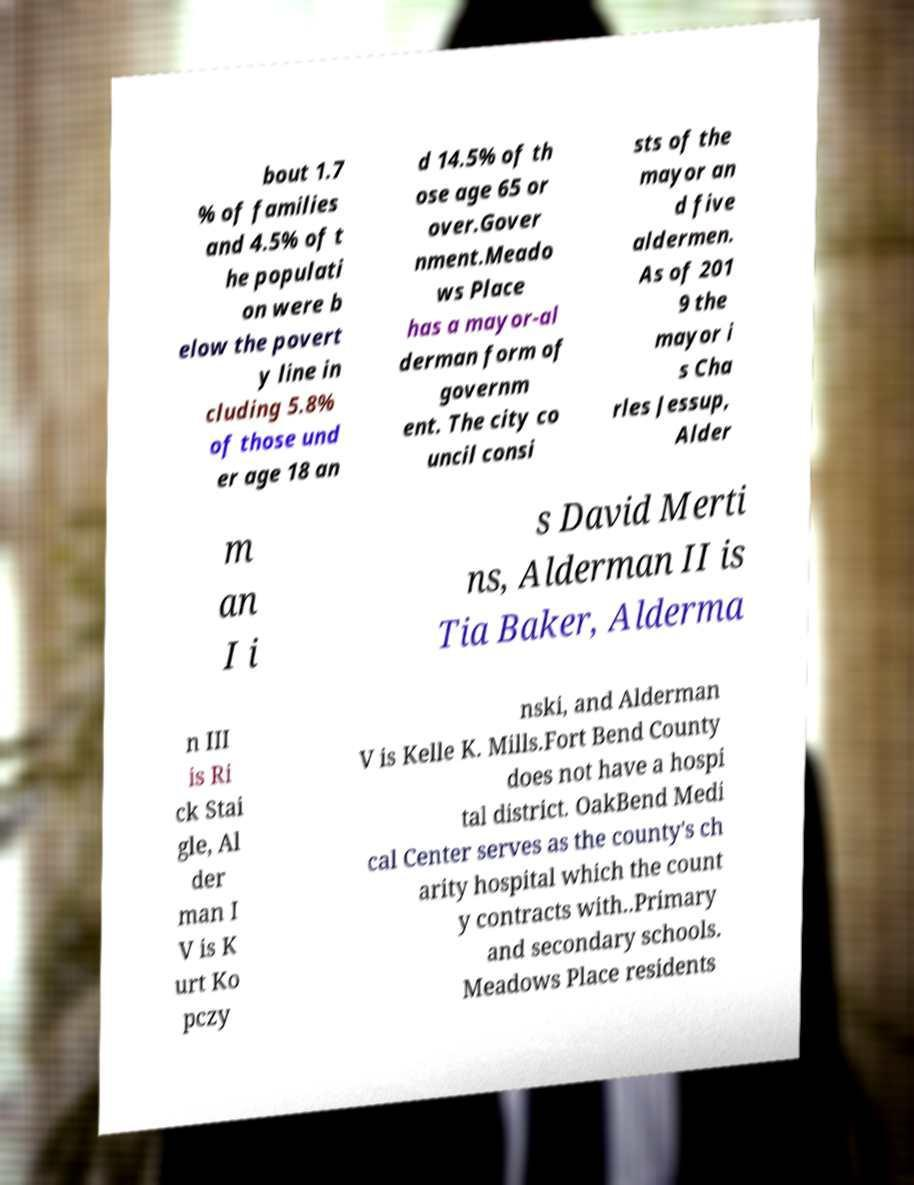What messages or text are displayed in this image? I need them in a readable, typed format. bout 1.7 % of families and 4.5% of t he populati on were b elow the povert y line in cluding 5.8% of those und er age 18 an d 14.5% of th ose age 65 or over.Gover nment.Meado ws Place has a mayor-al derman form of governm ent. The city co uncil consi sts of the mayor an d five aldermen. As of 201 9 the mayor i s Cha rles Jessup, Alder m an I i s David Merti ns, Alderman II is Tia Baker, Alderma n III is Ri ck Stai gle, Al der man I V is K urt Ko pczy nski, and Alderman V is Kelle K. Mills.Fort Bend County does not have a hospi tal district. OakBend Medi cal Center serves as the county's ch arity hospital which the count y contracts with..Primary and secondary schools. Meadows Place residents 